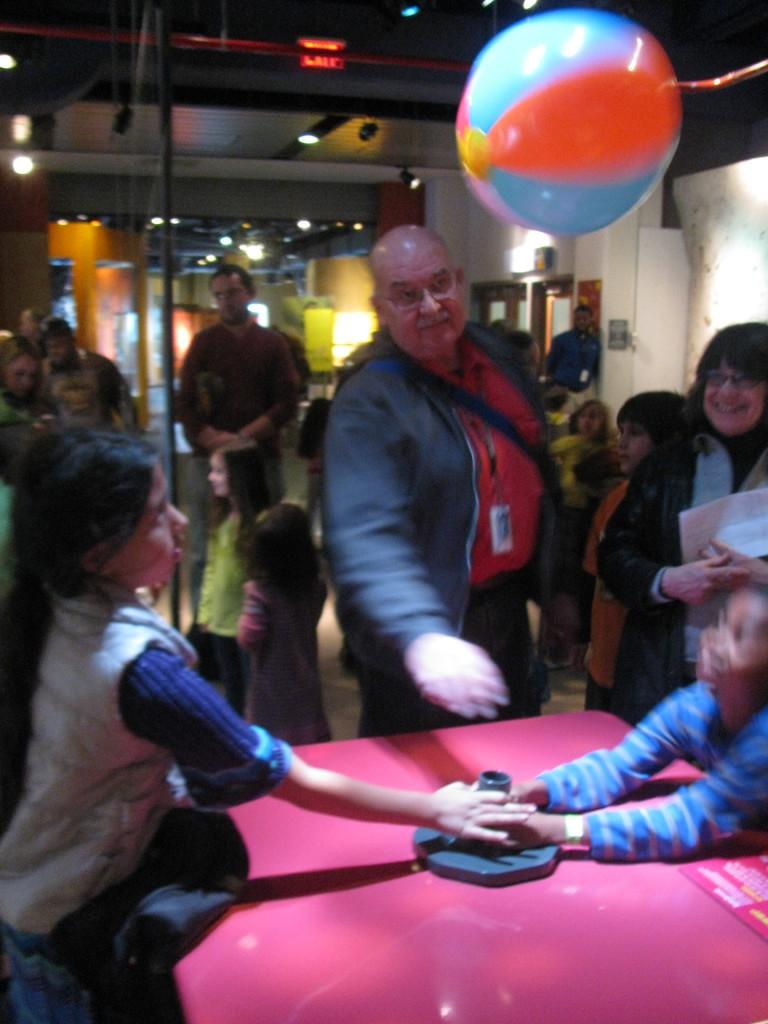What can be seen in the image involving human presence? There are people standing in the image. Where are the people standing? The people are standing on the floor. What type of lighting is present in the image? There are electric lights in the image. Are there any additional elements that contribute to the visual appeal of the image? Yes, there are decorations in the image. What type of rice is being served on the bear's base in the image? There is no bear or rice present in the image, so this question cannot be answered. 